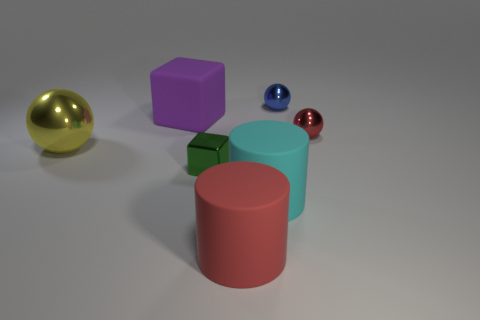The big thing on the left side of the big rubber object that is behind the metal cube to the left of the small red object is what shape?
Offer a very short reply. Sphere. Are there an equal number of red things that are on the right side of the blue ball and red things?
Your response must be concise. No. Do the large cyan matte object and the small blue thing have the same shape?
Ensure brevity in your answer.  No. What number of things are either large things that are left of the metallic block or large matte cylinders?
Make the answer very short. 4. Are there the same number of tiny red spheres that are right of the large purple rubber object and big cyan things in front of the cyan cylinder?
Keep it short and to the point. No. What number of other objects are the same shape as the cyan object?
Provide a short and direct response. 1. Does the block that is in front of the big rubber cube have the same size as the red thing that is in front of the big yellow metal object?
Your answer should be very brief. No. What number of cubes are either rubber things or tiny matte objects?
Provide a succinct answer. 1. How many metallic things are spheres or small green blocks?
Provide a short and direct response. 4. There is a cyan thing that is the same shape as the large red thing; what size is it?
Offer a very short reply. Large. 